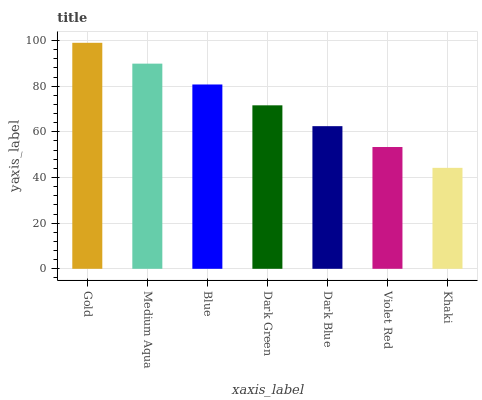Is Khaki the minimum?
Answer yes or no. Yes. Is Gold the maximum?
Answer yes or no. Yes. Is Medium Aqua the minimum?
Answer yes or no. No. Is Medium Aqua the maximum?
Answer yes or no. No. Is Gold greater than Medium Aqua?
Answer yes or no. Yes. Is Medium Aqua less than Gold?
Answer yes or no. Yes. Is Medium Aqua greater than Gold?
Answer yes or no. No. Is Gold less than Medium Aqua?
Answer yes or no. No. Is Dark Green the high median?
Answer yes or no. Yes. Is Dark Green the low median?
Answer yes or no. Yes. Is Dark Blue the high median?
Answer yes or no. No. Is Gold the low median?
Answer yes or no. No. 